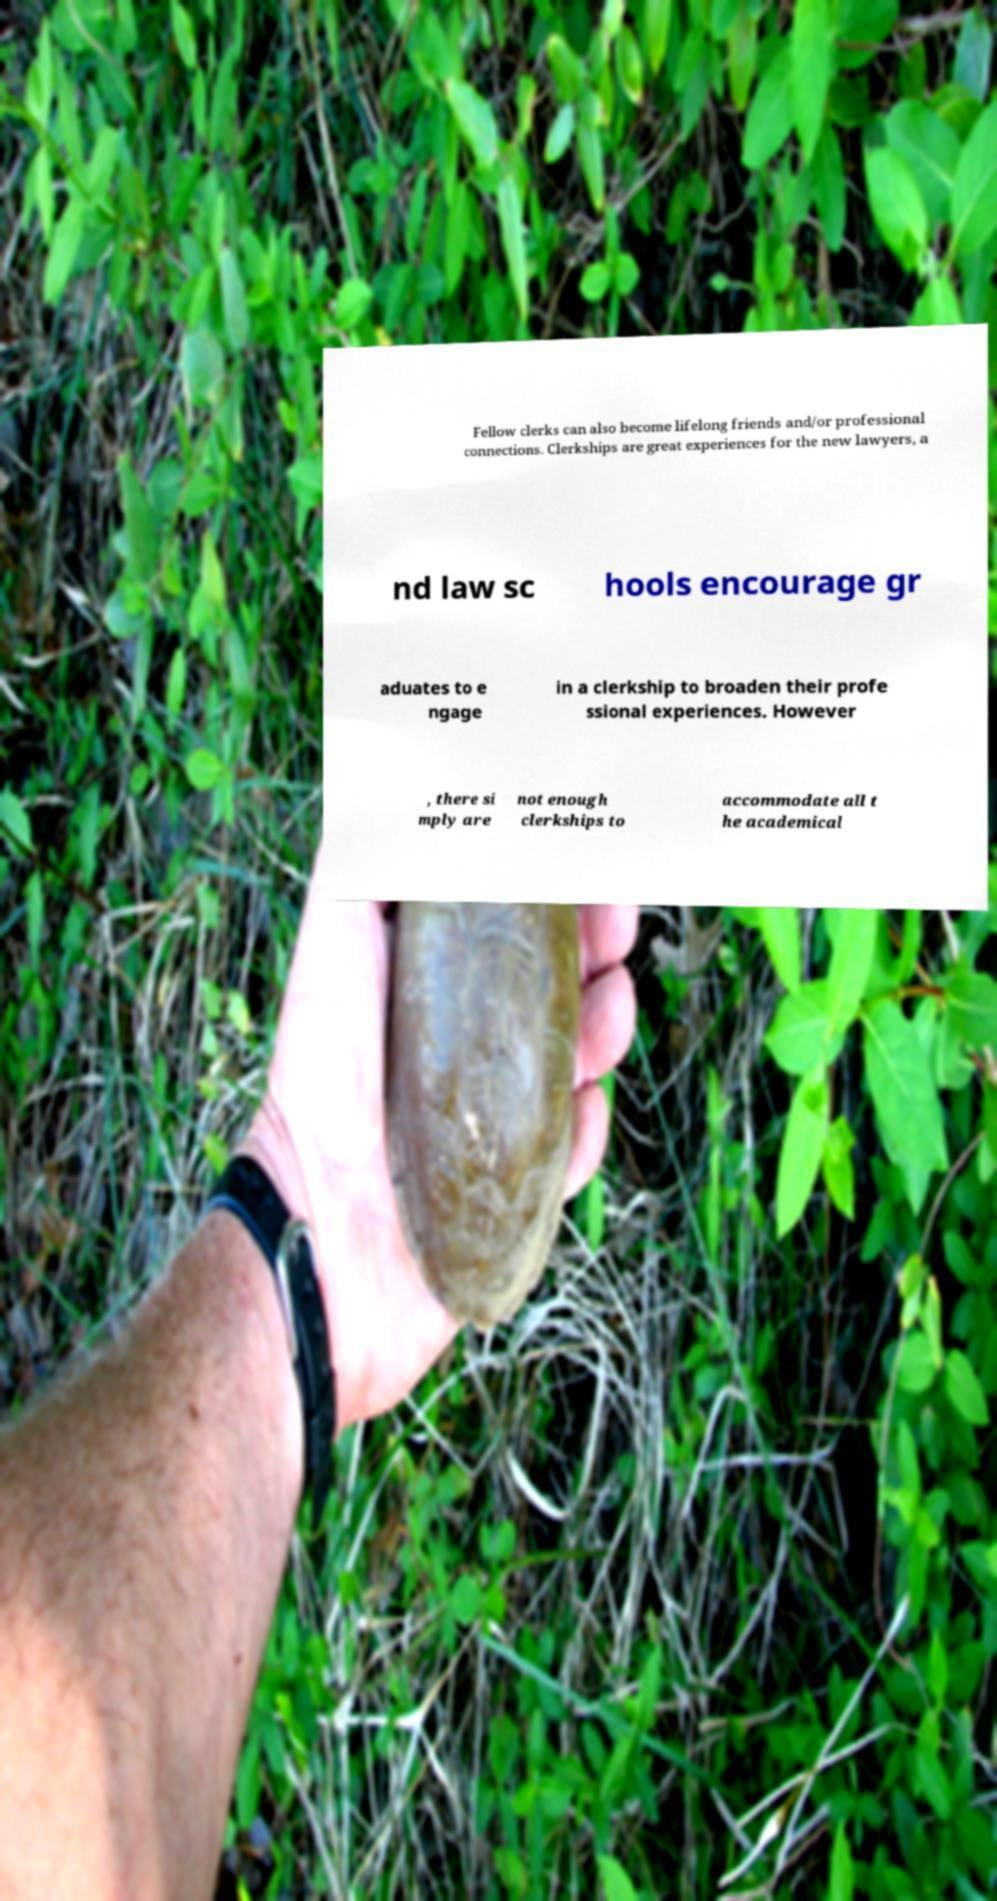Could you assist in decoding the text presented in this image and type it out clearly? Fellow clerks can also become lifelong friends and/or professional connections. Clerkships are great experiences for the new lawyers, a nd law sc hools encourage gr aduates to e ngage in a clerkship to broaden their profe ssional experiences. However , there si mply are not enough clerkships to accommodate all t he academical 